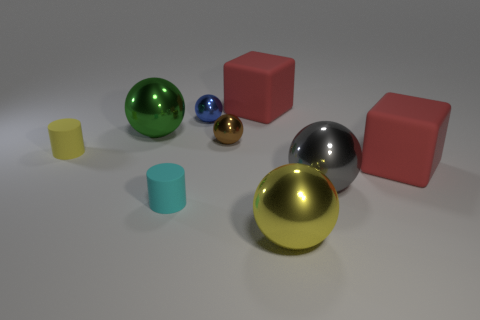Are there fewer yellow things that are right of the big gray thing than brown objects that are to the left of the tiny cyan cylinder?
Provide a short and direct response. No. There is a large gray metal ball; how many green things are on the left side of it?
Your response must be concise. 1. Are there any small cylinders that have the same material as the tiny blue sphere?
Your answer should be compact. No. Are there more small cyan things behind the gray metallic ball than small rubber objects that are on the right side of the yellow metallic sphere?
Your response must be concise. No. The gray shiny thing is what size?
Your answer should be compact. Large. What is the shape of the metallic thing in front of the tiny cyan cylinder?
Your response must be concise. Sphere. Does the cyan thing have the same shape as the small yellow object?
Offer a terse response. Yes. Are there the same number of rubber objects that are in front of the tiny blue shiny sphere and gray metallic spheres?
Make the answer very short. No. There is a brown metallic thing; what shape is it?
Your answer should be very brief. Sphere. Is the size of the block behind the tiny yellow cylinder the same as the metal ball in front of the cyan rubber object?
Provide a succinct answer. Yes. 